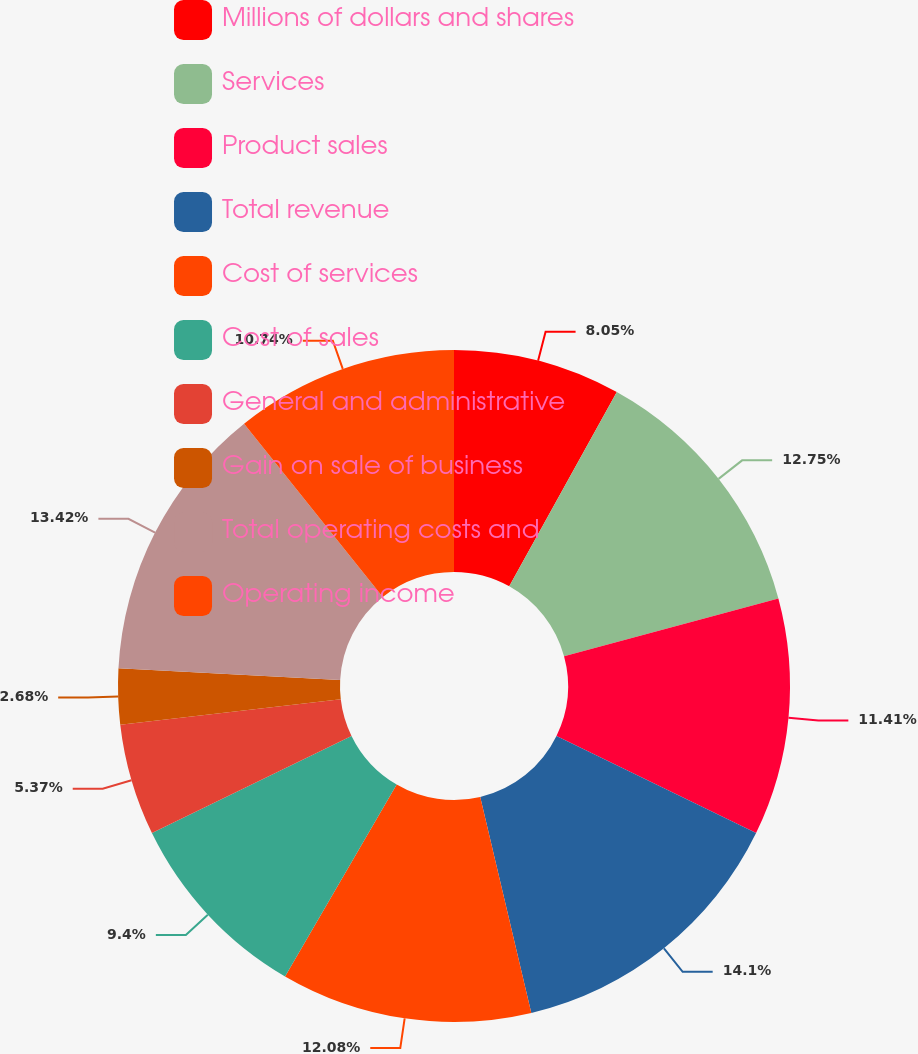Convert chart to OTSL. <chart><loc_0><loc_0><loc_500><loc_500><pie_chart><fcel>Millions of dollars and shares<fcel>Services<fcel>Product sales<fcel>Total revenue<fcel>Cost of services<fcel>Cost of sales<fcel>General and administrative<fcel>Gain on sale of business<fcel>Total operating costs and<fcel>Operating income<nl><fcel>8.05%<fcel>12.75%<fcel>11.41%<fcel>14.09%<fcel>12.08%<fcel>9.4%<fcel>5.37%<fcel>2.68%<fcel>13.42%<fcel>10.74%<nl></chart> 